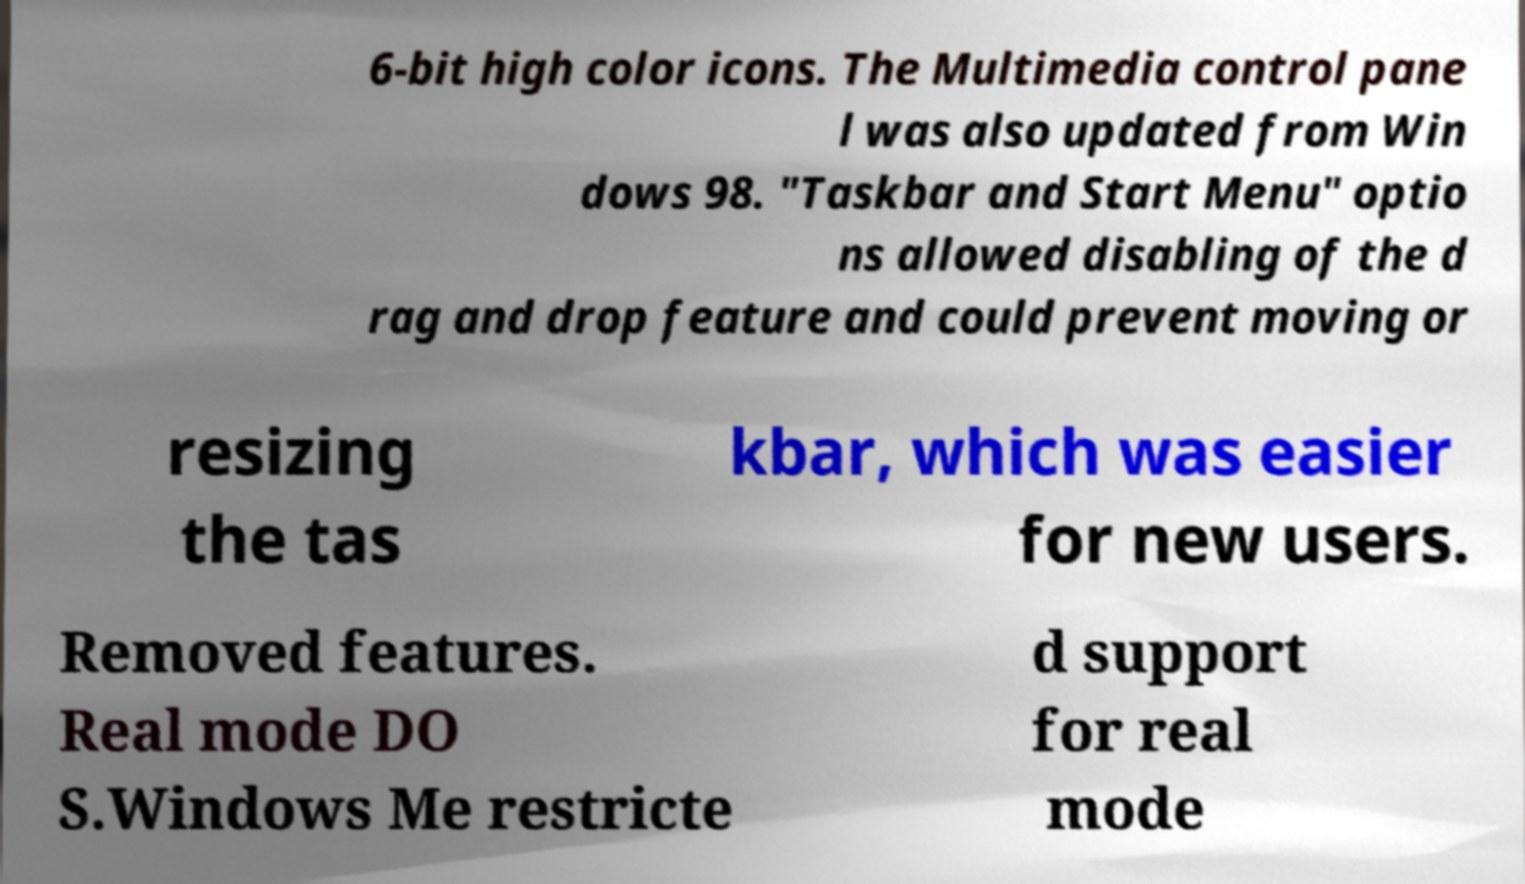For documentation purposes, I need the text within this image transcribed. Could you provide that? 6-bit high color icons. The Multimedia control pane l was also updated from Win dows 98. "Taskbar and Start Menu" optio ns allowed disabling of the d rag and drop feature and could prevent moving or resizing the tas kbar, which was easier for new users. Removed features. Real mode DO S.Windows Me restricte d support for real mode 